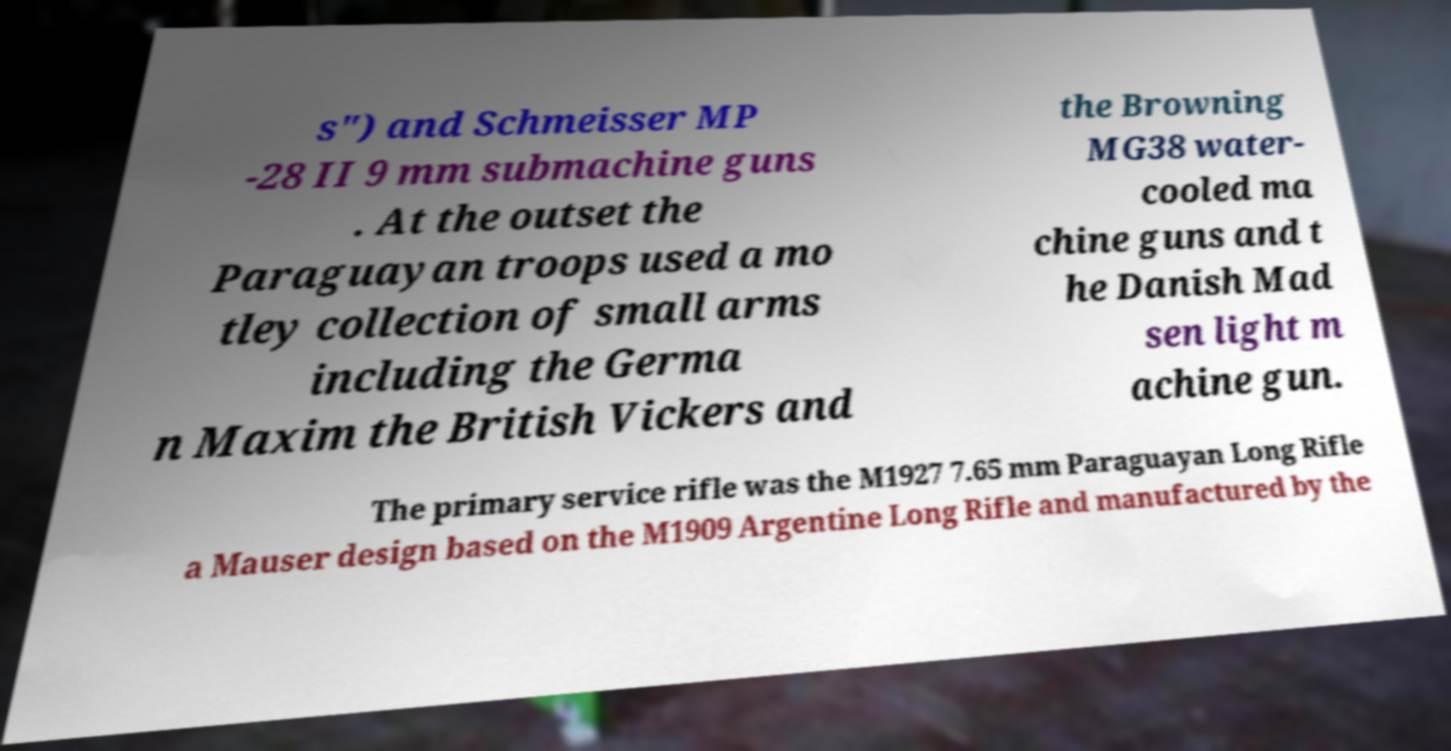Can you accurately transcribe the text from the provided image for me? s") and Schmeisser MP -28 II 9 mm submachine guns . At the outset the Paraguayan troops used a mo tley collection of small arms including the Germa n Maxim the British Vickers and the Browning MG38 water- cooled ma chine guns and t he Danish Mad sen light m achine gun. The primary service rifle was the M1927 7.65 mm Paraguayan Long Rifle a Mauser design based on the M1909 Argentine Long Rifle and manufactured by the 